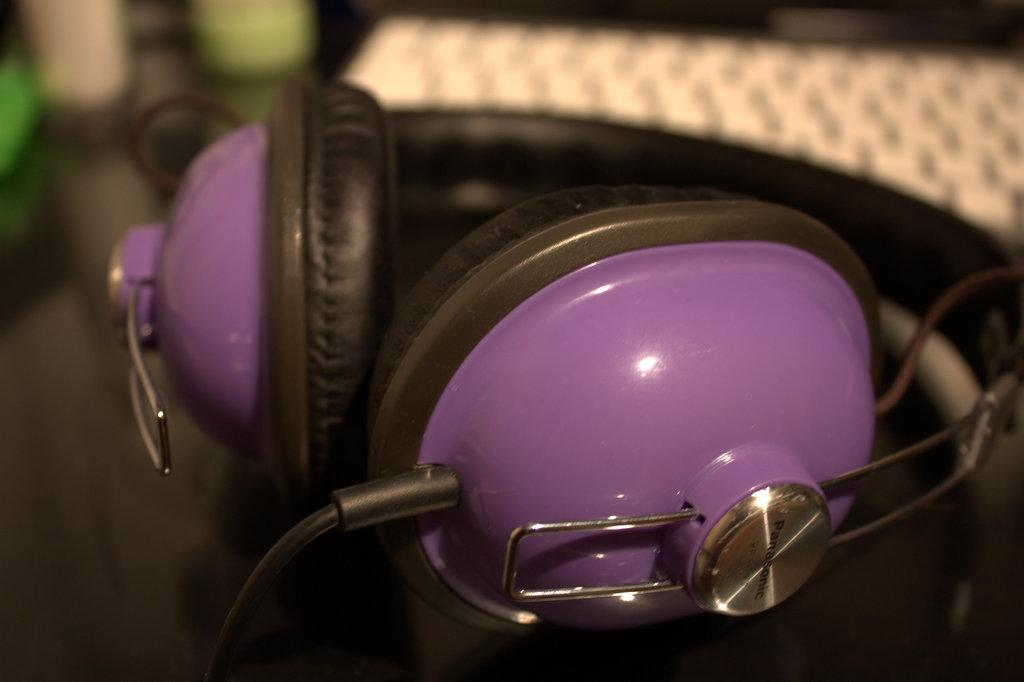What type of headphones can be seen in the image? There are purple and black headphones in the image. Can you describe the background of the image? The background of the image is blurred. What type of beam can be seen supporting the coast in the image? There is no beam or coast present in the image; it only features headphones. 